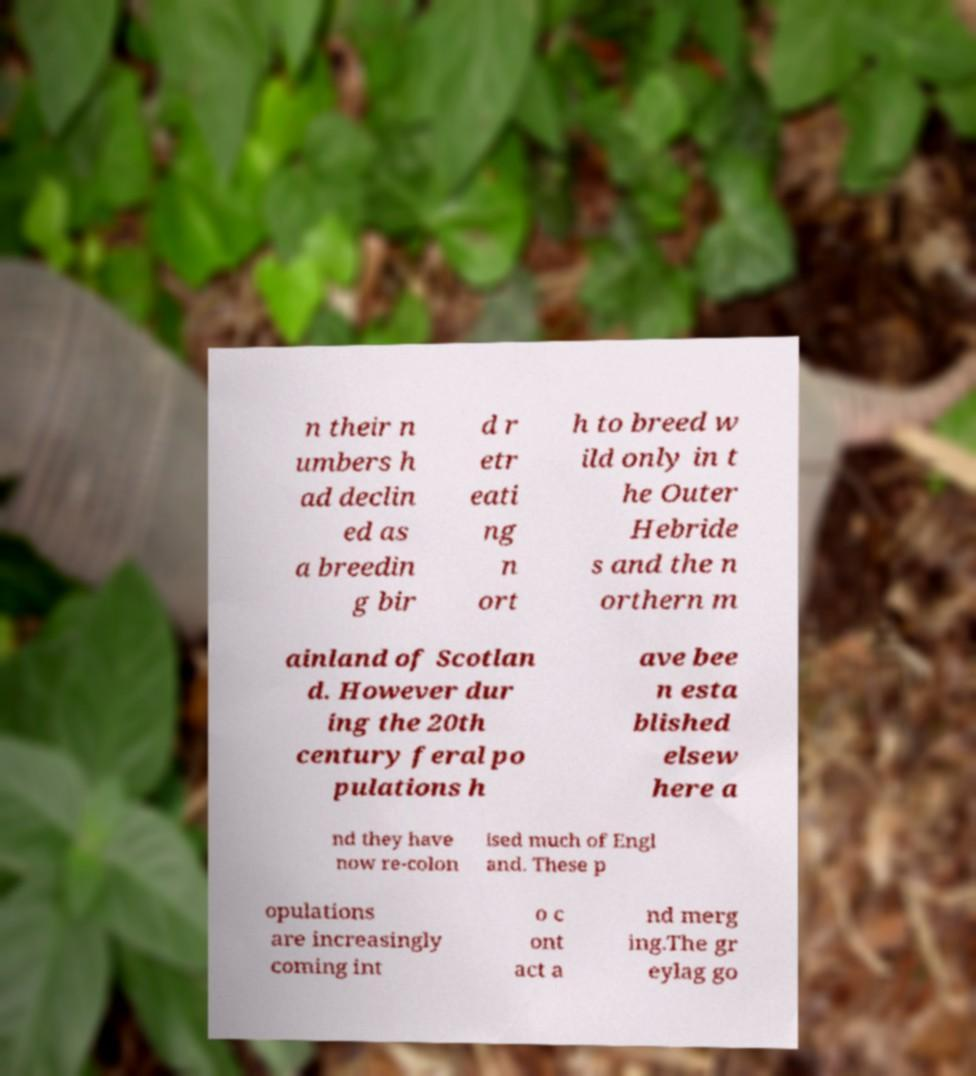Please read and relay the text visible in this image. What does it say? n their n umbers h ad declin ed as a breedin g bir d r etr eati ng n ort h to breed w ild only in t he Outer Hebride s and the n orthern m ainland of Scotlan d. However dur ing the 20th century feral po pulations h ave bee n esta blished elsew here a nd they have now re-colon ised much of Engl and. These p opulations are increasingly coming int o c ont act a nd merg ing.The gr eylag go 